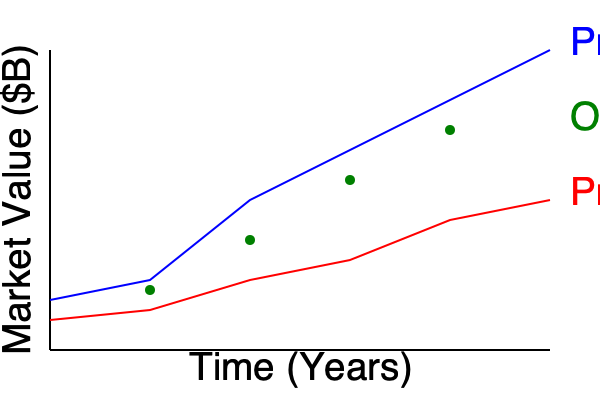Based on the market trends shown in the graph for Products A and B, and the scatter plot representing operational efficiency, what strategic decision should be made to optimize operations over the next 5 years? Provide a quantitative justification for your answer. To answer this question, we need to analyze the trends and data presented in the graph:

1. Market Trends:
   - Product A (blue line): Shows a strong upward trend, increasing from about $25B to $75B over the 5-year period.
   - Product B (red line): Shows a moderate upward trend, increasing from about $15B to $30B over the 5-year period.

2. Operational Efficiency (green scatter plot):
   - The scatter plot shows an improving trend in operational efficiency as time progresses.

3. Quantitative Analysis:
   - Calculate the growth rate for each product:
     Product A: $\frac{75B - 25B}{25B} \times 100\% = 200\%$ growth over 5 years
     Product B: $\frac{30B - 15B}{15B} \times 100\% = 100\%$ growth over 5 years

   - Compound Annual Growth Rate (CAGR):
     Product A: $(1 + 200\%)^{\frac{1}{5}} - 1 = 24.5\%$ per year
     Product B: $(1 + 100\%)^{\frac{1}{5}} - 1 = 14.9\%$ per year

4. Operational Efficiency Correlation:
   - The scatter plot suggests that operational efficiency improves as the market value of both products increases.

Based on this analysis, the strategic decision should be to focus on scaling up production and marketing for Product A, while maintaining steady growth for Product B. This decision is justified by:

1. Product A's higher growth rate (24.5% CAGR vs. 14.9% for Product B)
2. The positive correlation between market growth and operational efficiency

By prioritizing Product A, the company can capitalize on its stronger market performance while benefiting from improved operational efficiency as the market expands.
Answer: Focus on scaling Product A (24.5% CAGR) while maintaining Product B, leveraging improved operational efficiency. 